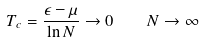<formula> <loc_0><loc_0><loc_500><loc_500>T _ { c } = \frac { \epsilon - \mu } { \ln N } \to 0 \quad N \to \infty</formula> 